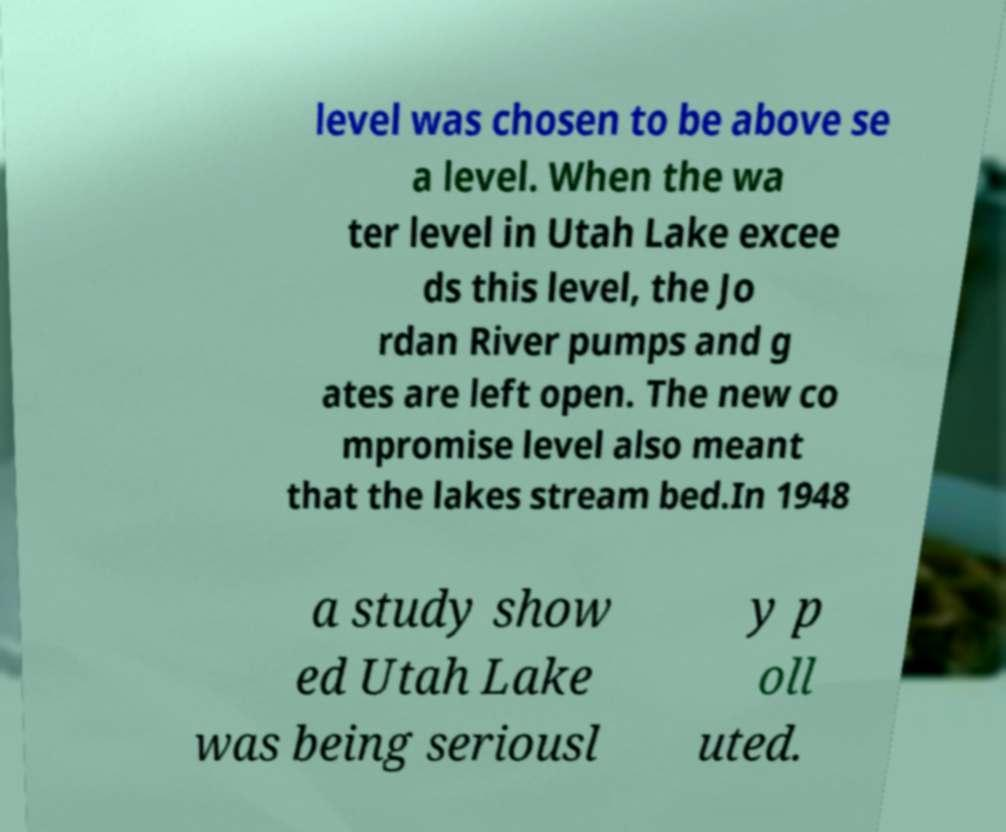Could you extract and type out the text from this image? level was chosen to be above se a level. When the wa ter level in Utah Lake excee ds this level, the Jo rdan River pumps and g ates are left open. The new co mpromise level also meant that the lakes stream bed.In 1948 a study show ed Utah Lake was being seriousl y p oll uted. 